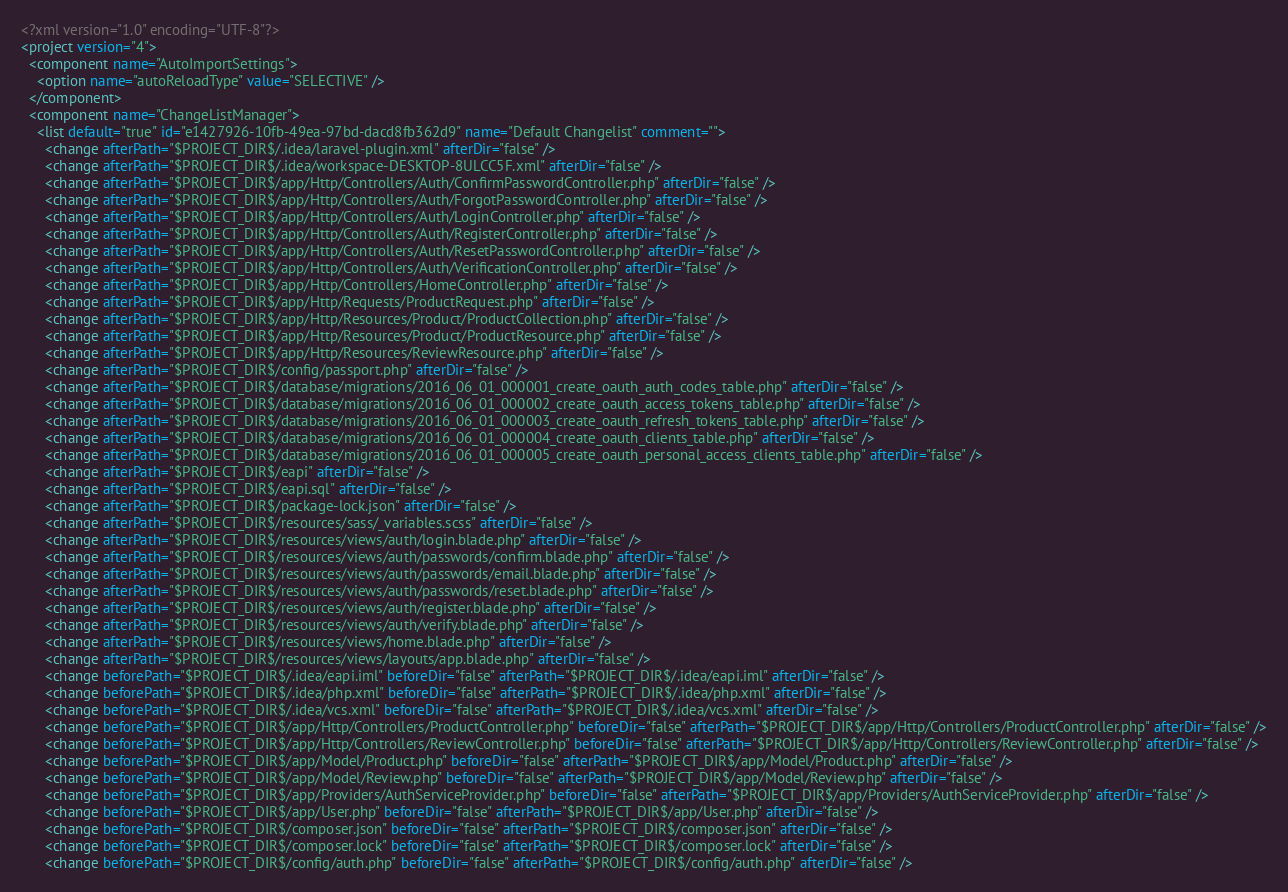Convert code to text. <code><loc_0><loc_0><loc_500><loc_500><_XML_><?xml version="1.0" encoding="UTF-8"?>
<project version="4">
  <component name="AutoImportSettings">
    <option name="autoReloadType" value="SELECTIVE" />
  </component>
  <component name="ChangeListManager">
    <list default="true" id="e1427926-10fb-49ea-97bd-dacd8fb362d9" name="Default Changelist" comment="">
      <change afterPath="$PROJECT_DIR$/.idea/laravel-plugin.xml" afterDir="false" />
      <change afterPath="$PROJECT_DIR$/.idea/workspace-DESKTOP-8ULCC5F.xml" afterDir="false" />
      <change afterPath="$PROJECT_DIR$/app/Http/Controllers/Auth/ConfirmPasswordController.php" afterDir="false" />
      <change afterPath="$PROJECT_DIR$/app/Http/Controllers/Auth/ForgotPasswordController.php" afterDir="false" />
      <change afterPath="$PROJECT_DIR$/app/Http/Controllers/Auth/LoginController.php" afterDir="false" />
      <change afterPath="$PROJECT_DIR$/app/Http/Controllers/Auth/RegisterController.php" afterDir="false" />
      <change afterPath="$PROJECT_DIR$/app/Http/Controllers/Auth/ResetPasswordController.php" afterDir="false" />
      <change afterPath="$PROJECT_DIR$/app/Http/Controllers/Auth/VerificationController.php" afterDir="false" />
      <change afterPath="$PROJECT_DIR$/app/Http/Controllers/HomeController.php" afterDir="false" />
      <change afterPath="$PROJECT_DIR$/app/Http/Requests/ProductRequest.php" afterDir="false" />
      <change afterPath="$PROJECT_DIR$/app/Http/Resources/Product/ProductCollection.php" afterDir="false" />
      <change afterPath="$PROJECT_DIR$/app/Http/Resources/Product/ProductResource.php" afterDir="false" />
      <change afterPath="$PROJECT_DIR$/app/Http/Resources/ReviewResource.php" afterDir="false" />
      <change afterPath="$PROJECT_DIR$/config/passport.php" afterDir="false" />
      <change afterPath="$PROJECT_DIR$/database/migrations/2016_06_01_000001_create_oauth_auth_codes_table.php" afterDir="false" />
      <change afterPath="$PROJECT_DIR$/database/migrations/2016_06_01_000002_create_oauth_access_tokens_table.php" afterDir="false" />
      <change afterPath="$PROJECT_DIR$/database/migrations/2016_06_01_000003_create_oauth_refresh_tokens_table.php" afterDir="false" />
      <change afterPath="$PROJECT_DIR$/database/migrations/2016_06_01_000004_create_oauth_clients_table.php" afterDir="false" />
      <change afterPath="$PROJECT_DIR$/database/migrations/2016_06_01_000005_create_oauth_personal_access_clients_table.php" afterDir="false" />
      <change afterPath="$PROJECT_DIR$/eapi" afterDir="false" />
      <change afterPath="$PROJECT_DIR$/eapi.sql" afterDir="false" />
      <change afterPath="$PROJECT_DIR$/package-lock.json" afterDir="false" />
      <change afterPath="$PROJECT_DIR$/resources/sass/_variables.scss" afterDir="false" />
      <change afterPath="$PROJECT_DIR$/resources/views/auth/login.blade.php" afterDir="false" />
      <change afterPath="$PROJECT_DIR$/resources/views/auth/passwords/confirm.blade.php" afterDir="false" />
      <change afterPath="$PROJECT_DIR$/resources/views/auth/passwords/email.blade.php" afterDir="false" />
      <change afterPath="$PROJECT_DIR$/resources/views/auth/passwords/reset.blade.php" afterDir="false" />
      <change afterPath="$PROJECT_DIR$/resources/views/auth/register.blade.php" afterDir="false" />
      <change afterPath="$PROJECT_DIR$/resources/views/auth/verify.blade.php" afterDir="false" />
      <change afterPath="$PROJECT_DIR$/resources/views/home.blade.php" afterDir="false" />
      <change afterPath="$PROJECT_DIR$/resources/views/layouts/app.blade.php" afterDir="false" />
      <change beforePath="$PROJECT_DIR$/.idea/eapi.iml" beforeDir="false" afterPath="$PROJECT_DIR$/.idea/eapi.iml" afterDir="false" />
      <change beforePath="$PROJECT_DIR$/.idea/php.xml" beforeDir="false" afterPath="$PROJECT_DIR$/.idea/php.xml" afterDir="false" />
      <change beforePath="$PROJECT_DIR$/.idea/vcs.xml" beforeDir="false" afterPath="$PROJECT_DIR$/.idea/vcs.xml" afterDir="false" />
      <change beforePath="$PROJECT_DIR$/app/Http/Controllers/ProductController.php" beforeDir="false" afterPath="$PROJECT_DIR$/app/Http/Controllers/ProductController.php" afterDir="false" />
      <change beforePath="$PROJECT_DIR$/app/Http/Controllers/ReviewController.php" beforeDir="false" afterPath="$PROJECT_DIR$/app/Http/Controllers/ReviewController.php" afterDir="false" />
      <change beforePath="$PROJECT_DIR$/app/Model/Product.php" beforeDir="false" afterPath="$PROJECT_DIR$/app/Model/Product.php" afterDir="false" />
      <change beforePath="$PROJECT_DIR$/app/Model/Review.php" beforeDir="false" afterPath="$PROJECT_DIR$/app/Model/Review.php" afterDir="false" />
      <change beforePath="$PROJECT_DIR$/app/Providers/AuthServiceProvider.php" beforeDir="false" afterPath="$PROJECT_DIR$/app/Providers/AuthServiceProvider.php" afterDir="false" />
      <change beforePath="$PROJECT_DIR$/app/User.php" beforeDir="false" afterPath="$PROJECT_DIR$/app/User.php" afterDir="false" />
      <change beforePath="$PROJECT_DIR$/composer.json" beforeDir="false" afterPath="$PROJECT_DIR$/composer.json" afterDir="false" />
      <change beforePath="$PROJECT_DIR$/composer.lock" beforeDir="false" afterPath="$PROJECT_DIR$/composer.lock" afterDir="false" />
      <change beforePath="$PROJECT_DIR$/config/auth.php" beforeDir="false" afterPath="$PROJECT_DIR$/config/auth.php" afterDir="false" /></code> 